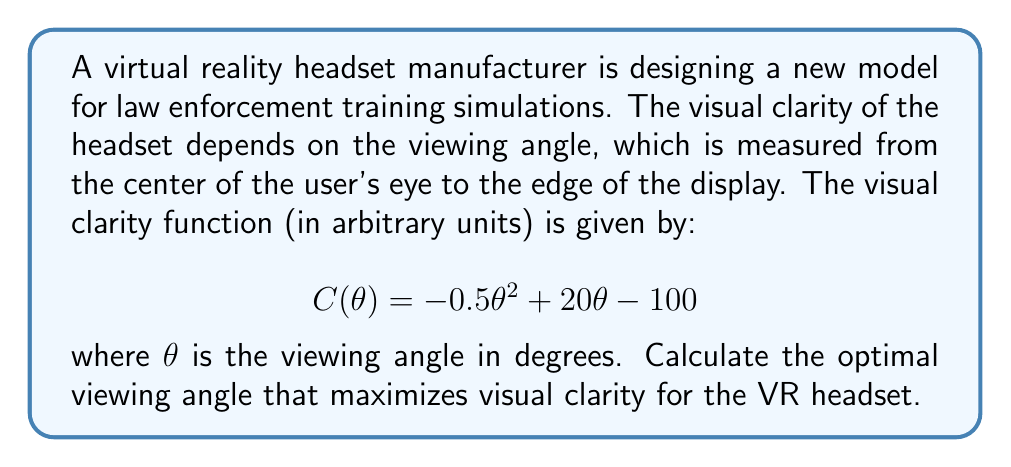Provide a solution to this math problem. To find the optimal viewing angle that maximizes visual clarity, we need to find the maximum of the function $C(\theta)$. This can be done by following these steps:

1. Find the derivative of $C(\theta)$ with respect to $\theta$:
   $$C'(\theta) = \frac{d}{d\theta}(-0.5\theta^2 + 20\theta - 100)$$
   $$C'(\theta) = -\theta + 20$$

2. Set the derivative equal to zero to find the critical point:
   $$C'(\theta) = 0$$
   $$-\theta + 20 = 0$$
   $$\theta = 20$$

3. Verify that this critical point is a maximum by checking the second derivative:
   $$C''(\theta) = \frac{d}{d\theta}(-\theta + 20) = -1$$

   Since $C''(\theta) < 0$ for all $\theta$, the critical point at $\theta = 20$ is a maximum.

4. Therefore, the optimal viewing angle that maximizes visual clarity is 20 degrees.

To further illustrate this, we can visualize the function:

[asy]
import graph;
size(200,150);
real f(real x) {return -0.5*x^2 + 20*x - 100;}
draw(graph(f,0,40));
dot((20,f(20)));
label("Maximum",(20,f(20)),N);
xaxis("θ (degrees)",0,40,Arrow);
yaxis("C(θ)",0,100,Arrow);
[/asy]

The graph shows that the function reaches its maximum at $\theta = 20$ degrees.
Answer: The optimal viewing angle for the VR headset that maximizes visual clarity is 20 degrees. 